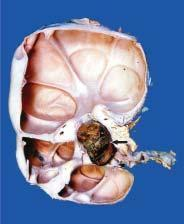s bone biopsy seen to extend into renal p arenchyma, compressing the cortex as a thin rim at the periphery?
Answer the question using a single word or phrase. No 